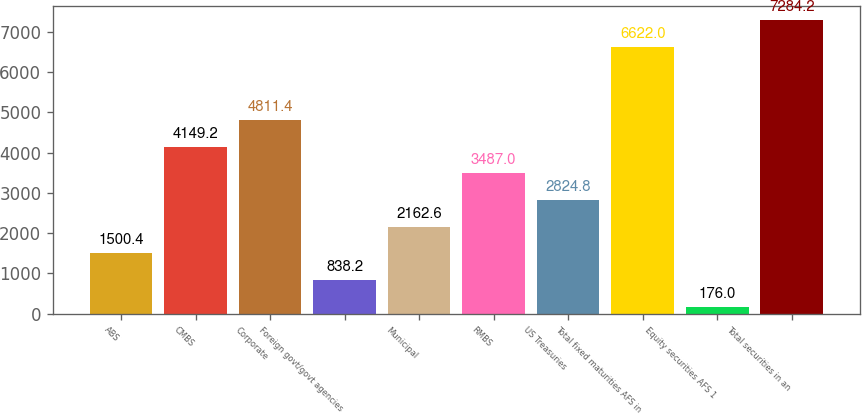Convert chart. <chart><loc_0><loc_0><loc_500><loc_500><bar_chart><fcel>ABS<fcel>CMBS<fcel>Corporate<fcel>Foreign govt/govt agencies<fcel>Municipal<fcel>RMBS<fcel>US Treasuries<fcel>Total fixed maturities AFS in<fcel>Equity securities AFS 1<fcel>Total securities in an<nl><fcel>1500.4<fcel>4149.2<fcel>4811.4<fcel>838.2<fcel>2162.6<fcel>3487<fcel>2824.8<fcel>6622<fcel>176<fcel>7284.2<nl></chart> 